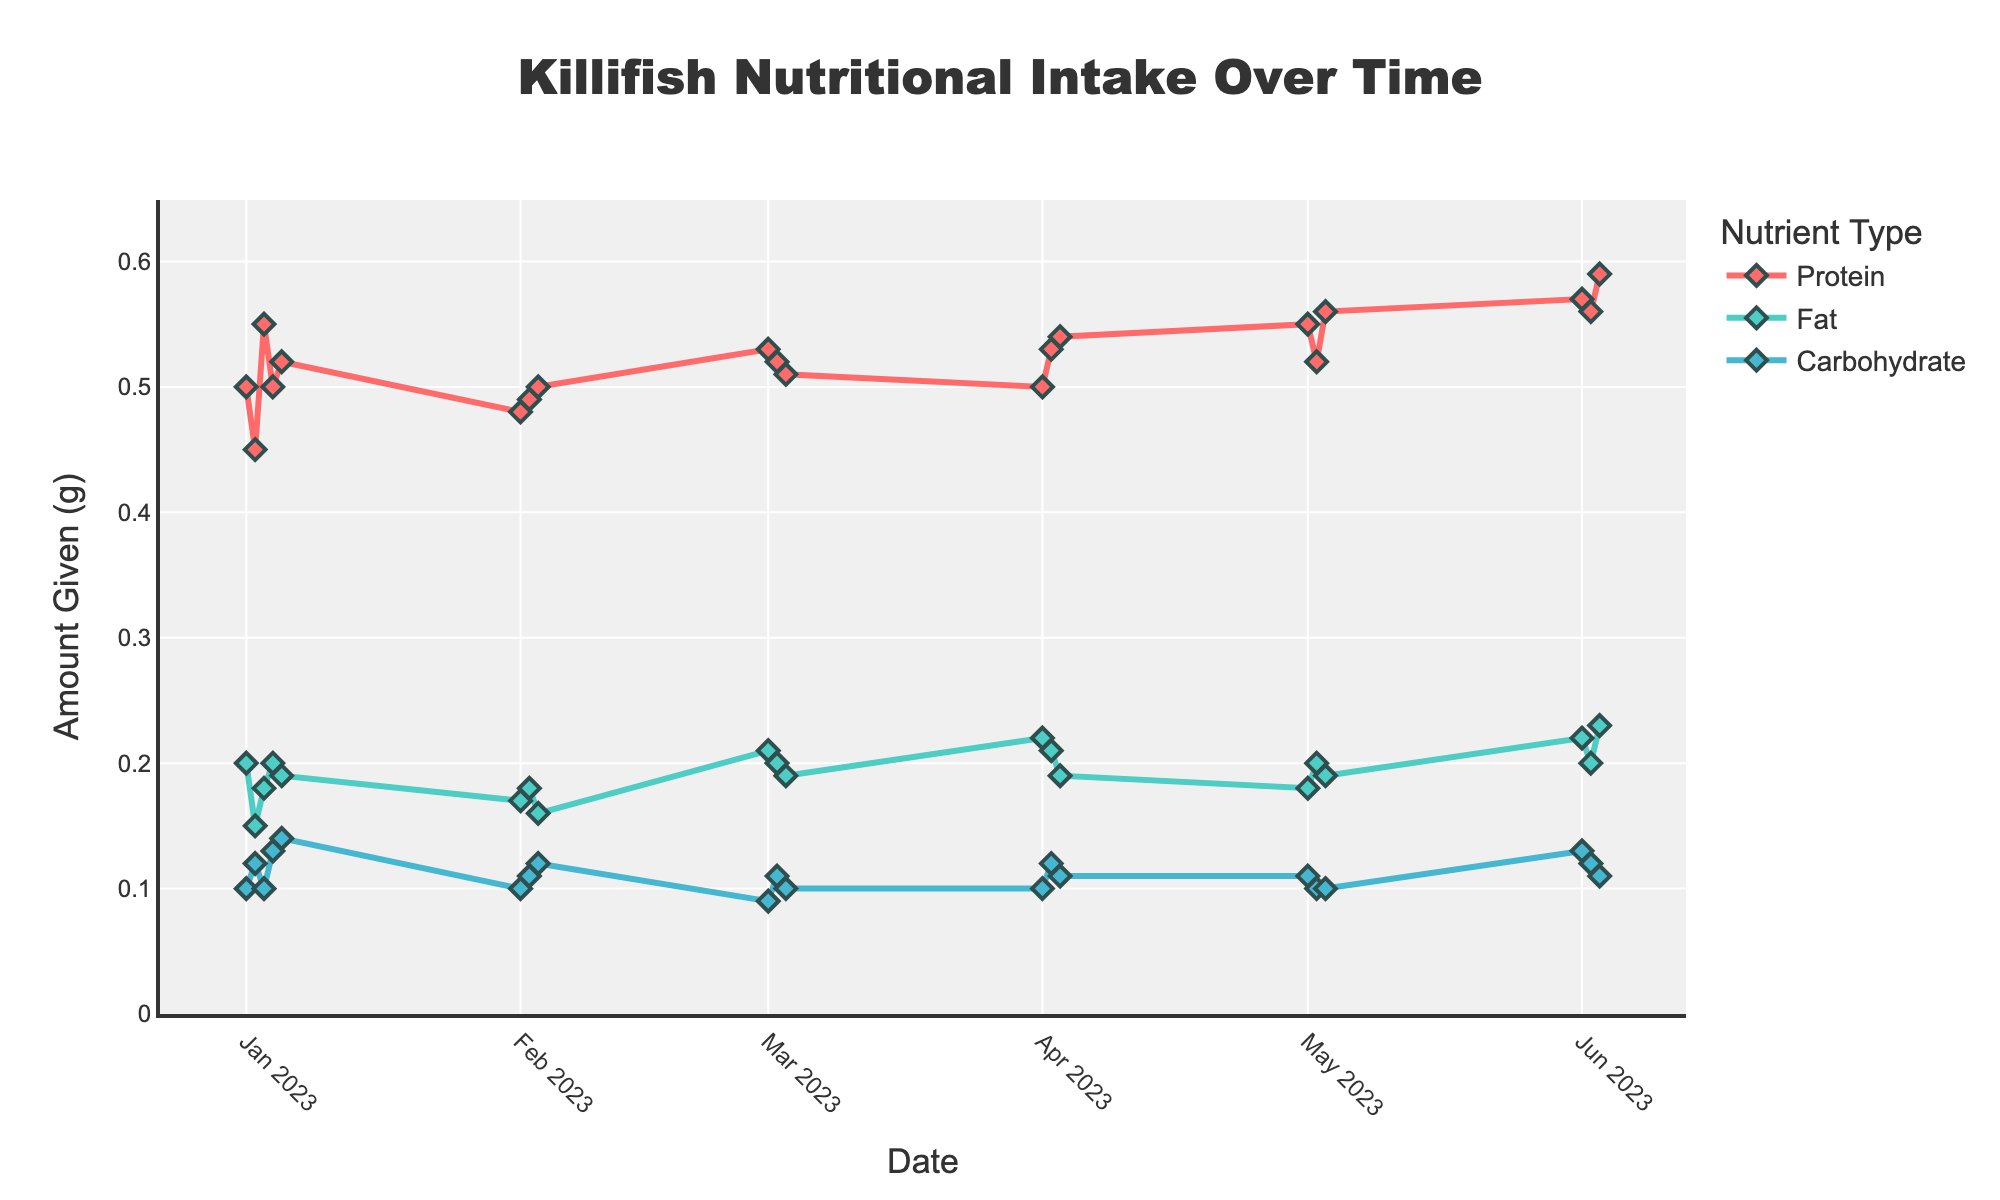What is the title of the plot? The title of the plot is usually located at the top of the figure, clearly stating the main focus of the visual data representation. In this case, it reads "Killifish Nutritional Intake Over Time".
Answer: Killifish Nutritional Intake Over Time What are the nutrients monitored in this plot? The nutrients monitored can be identified by the legend or the lines/markers' names on the plot. Here, they are represented as Protein, Fat, and Carbohydrate.
Answer: Protein, Fat, Carbohydrate On which date was the highest amount of protein given? Examine the scatter plot line for Protein to identify the peak value. The highest data point corresponding to protein is observed on 2023-06-03.
Answer: 2023-06-03 Which nutrient showed the most fluctuation over the six months? Fluctuations can be observed by comparing the variance in the lines for each nutrient. Protein shows the most fluctuation, with peaks and troughs throughout the six months.
Answer: Protein What is the average amount of protein given in the month of March 2023? To calculate this, identify the protein values in the month of March: [0.53, 0.52, 0.51]. Sum these values and divide by the number of values. (0.53 + 0.52 + 0.51) / 3 = 0.52
Answer: 0.52 Which nutrient is generally given in the smallest amount? By comparing the lines' y-axis positions, it's evident that Carbohydrate consistently has the lowest values out of the three nutrients.
Answer: Carbohydrate What trend can be seen in the amount of Fat given from January to June 2023? To determine the trend, observe the trajectory of the Fat line. It starts relatively low in January then increases slightly towards June.
Answer: Increasing On which date were the nutrients given consistently in equal amounts relative to previous dates? Look for a date where all nutrient lines intersect at similar values compared to previous dates. This situation is observed on 2023-01-01 and 2023-01-04.
Answer: 2023-01-01 and 2023-01-04 Between which months is there a noticeable increase in the amount of Carbohydrate given? Identify when the carbohydrate line shows an upward shift. Noticeable changes are present from February to March.
Answer: February to March 